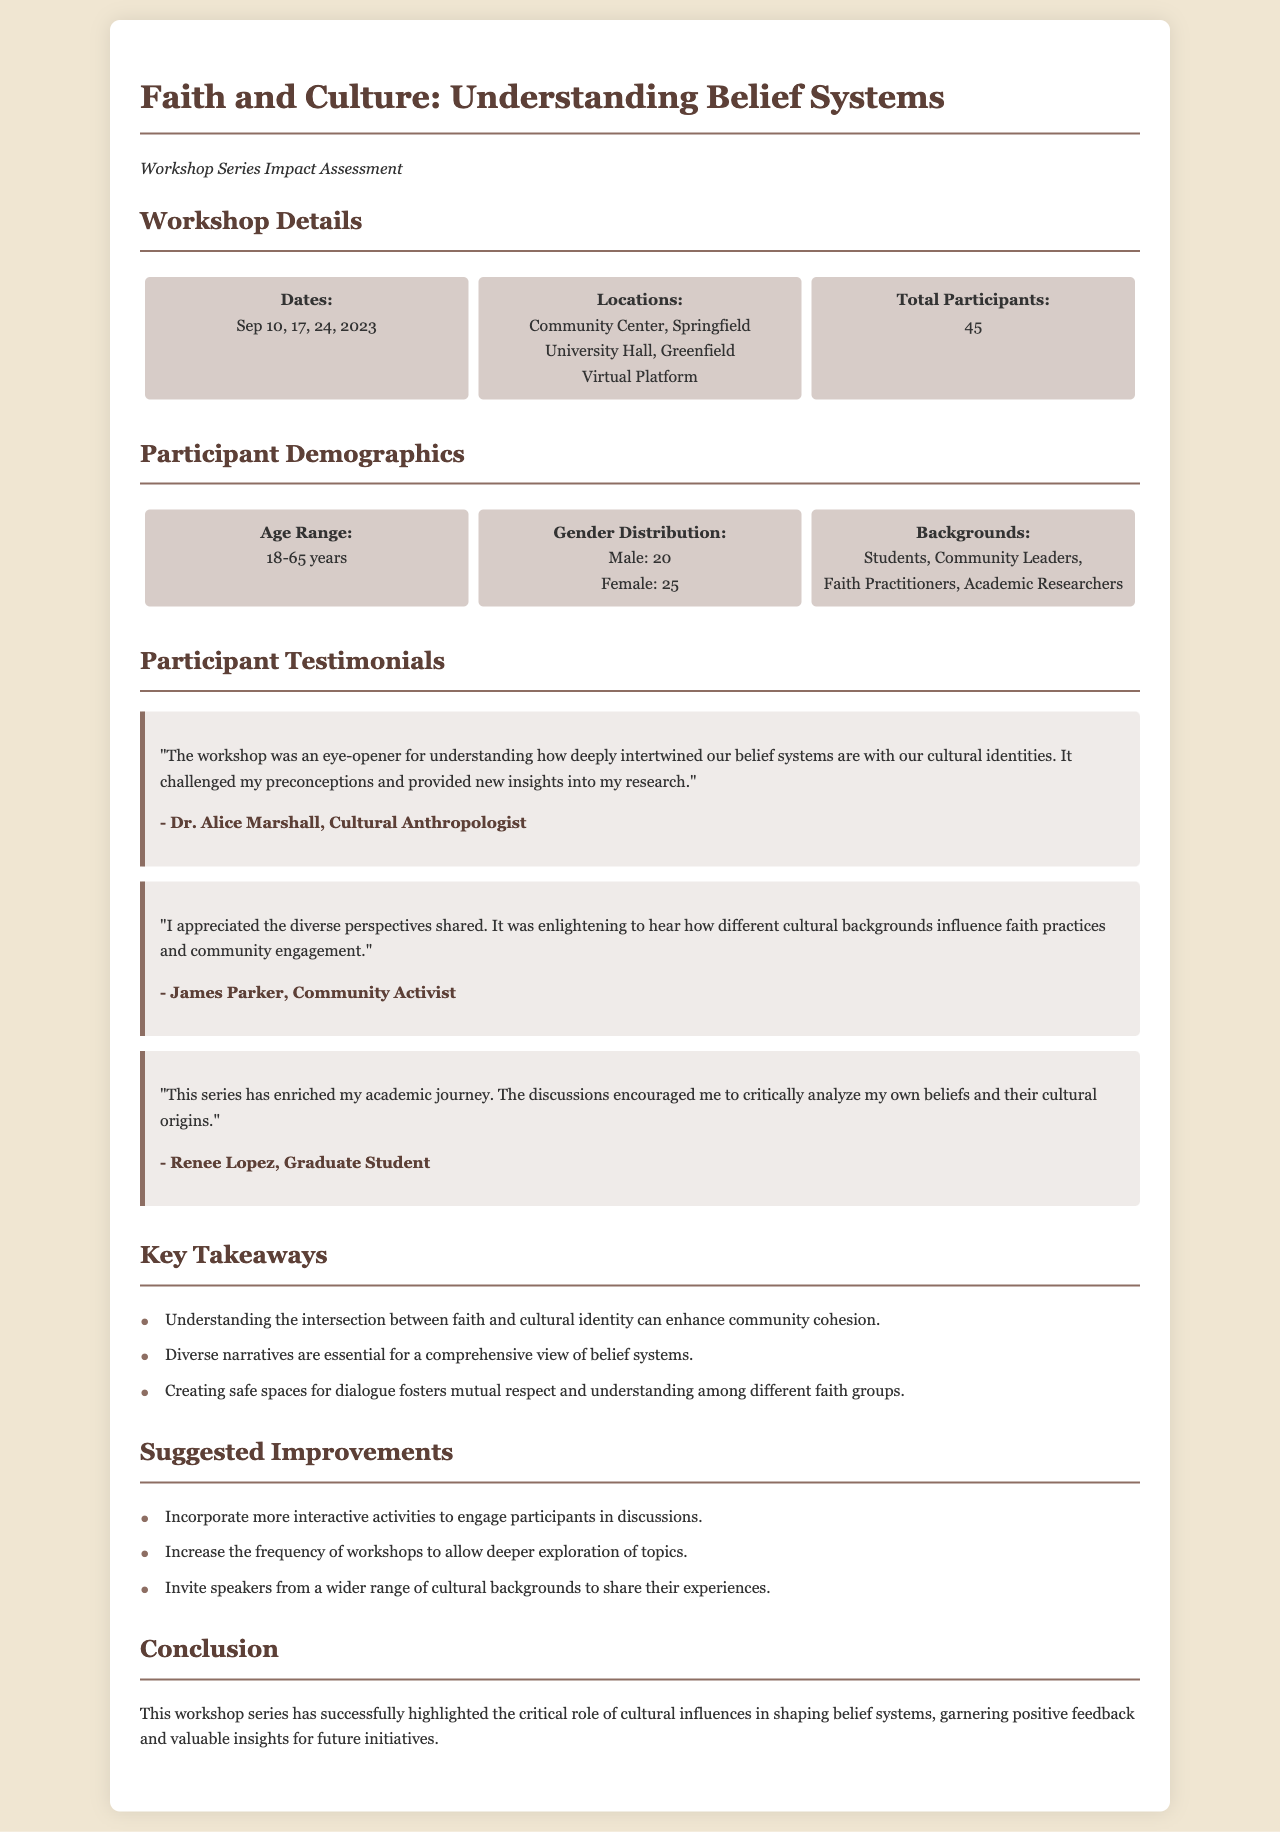what were the workshop dates? The workshop dates are explicitly mentioned in the document as September 10, 17, and 24, 2023.
Answer: September 10, 17, 24, 2023 what was the total number of participants? The total number of participants is provided in the statistics section of the document.
Answer: 45 who is a participant that provided a testimonial? Testimonial authors are listed in the participant testimonials section, one such author is Dr. Alice Marshall.
Answer: Dr. Alice Marshall what is a key takeaway from the workshop? The document lists key takeaways, one of which is understanding the intersection between faith and cultural identity can enhance community cohesion.
Answer: Understanding the intersection between faith and cultural identity can enhance community cohesion what improvement is suggested for future workshops? Suggested improvements are listed in the document, one suggestion is to incorporate more interactive activities to engage participants in discussions.
Answer: Incorporate more interactive activities to engage participants in discussions how many male participants were there? The gender distribution section specifies the number of male participants.
Answer: 20 what was one of the backgrounds of the participants? The document outlines various participant backgrounds, one of which is faith practitioners.
Answer: Faith Practitioners who expressed appreciation for diverse perspectives? The testimonial section contains a quote from a participant who appreciated diverse perspectives, which was James Parker.
Answer: James Parker 